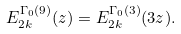Convert formula to latex. <formula><loc_0><loc_0><loc_500><loc_500>E _ { 2 k } ^ { \Gamma _ { 0 } ( 9 ) } ( z ) = E _ { 2 k } ^ { \Gamma _ { 0 } ( 3 ) } ( 3 z ) .</formula> 